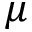Convert formula to latex. <formula><loc_0><loc_0><loc_500><loc_500>\mu</formula> 